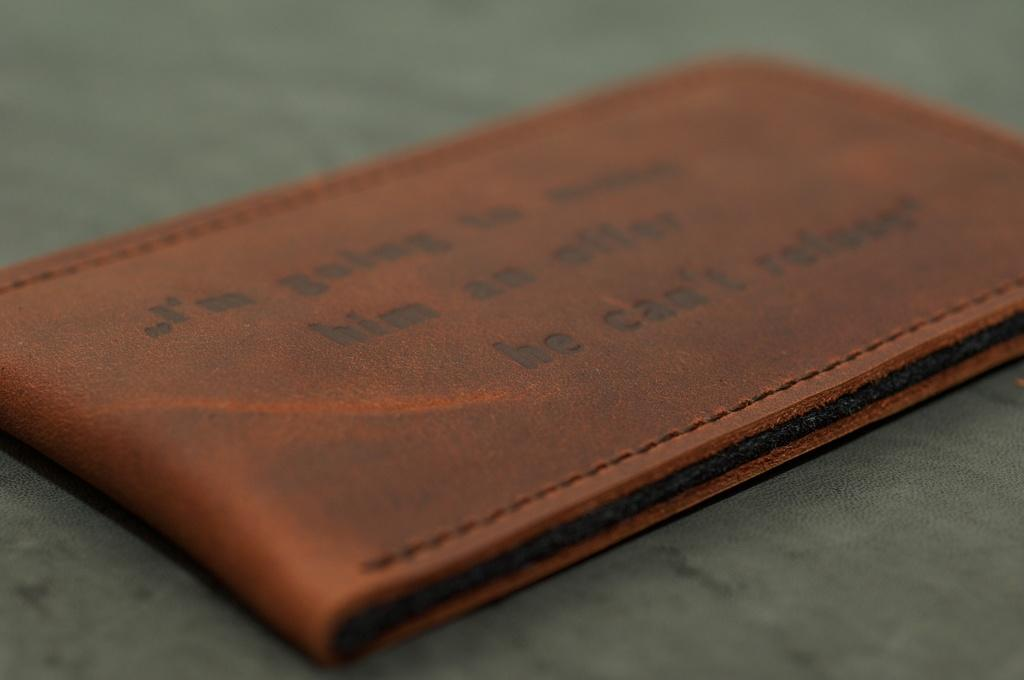What type of material is the object in the image made of? The object in the image is made of leather. What can be found on the surface of the leather object? The leather object has text on its surface. What is the shape of the elbow in the image? There is no elbow present in the image; it features a leather object with text on its surface. 